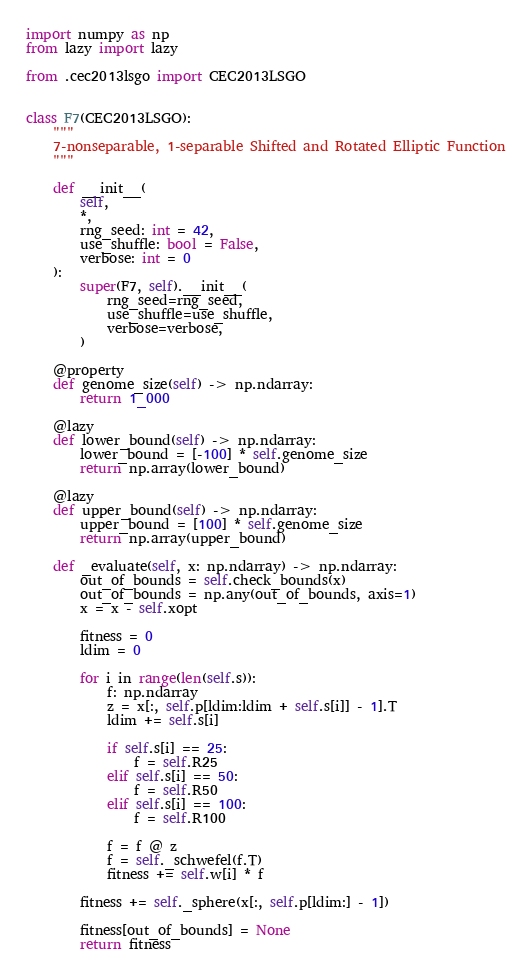Convert code to text. <code><loc_0><loc_0><loc_500><loc_500><_Python_>import numpy as np
from lazy import lazy

from .cec2013lsgo import CEC2013LSGO


class F7(CEC2013LSGO):
    """
    7-nonseparable, 1-separable Shifted and Rotated Elliptic Function
    """

    def __init__(
        self,
        *,
        rng_seed: int = 42,
        use_shuffle: bool = False,
        verbose: int = 0
    ):
        super(F7, self).__init__(
            rng_seed=rng_seed,
            use_shuffle=use_shuffle,
            verbose=verbose,
        )

    @property
    def genome_size(self) -> np.ndarray:
        return 1_000

    @lazy
    def lower_bound(self) -> np.ndarray:
        lower_bound = [-100] * self.genome_size
        return np.array(lower_bound)

    @lazy
    def upper_bound(self) -> np.ndarray:
        upper_bound = [100] * self.genome_size
        return np.array(upper_bound)

    def _evaluate(self, x: np.ndarray) -> np.ndarray:
        out_of_bounds = self.check_bounds(x)
        out_of_bounds = np.any(out_of_bounds, axis=1)
        x = x - self.xopt

        fitness = 0
        ldim = 0

        for i in range(len(self.s)):
            f: np.ndarray
            z = x[:, self.p[ldim:ldim + self.s[i]] - 1].T
            ldim += self.s[i]

            if self.s[i] == 25:
                f = self.R25
            elif self.s[i] == 50:
                f = self.R50
            elif self.s[i] == 100:
                f = self.R100

            f = f @ z
            f = self._schwefel(f.T)
            fitness += self.w[i] * f

        fitness += self._sphere(x[:, self.p[ldim:] - 1])

        fitness[out_of_bounds] = None
        return fitness
</code> 